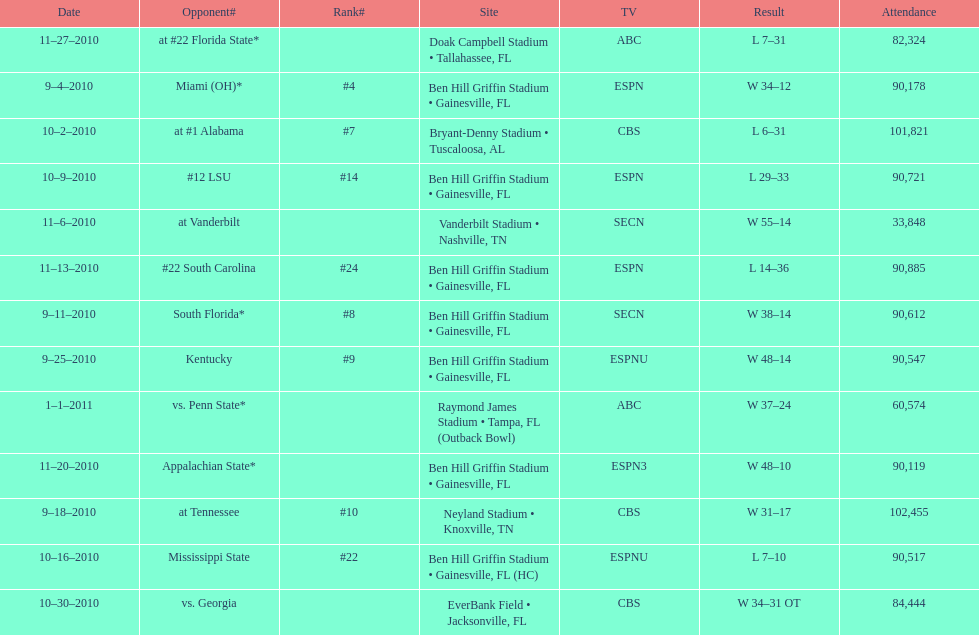In the 2010-2011 season, what was the count of games that took place at ben hill griffin stadium? 7. 